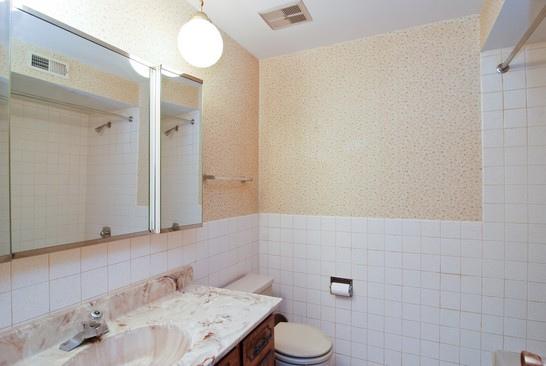Is the light on?
Give a very brief answer. Yes. Is their toilet paper?
Write a very short answer. Yes. Is this a clean room?
Keep it brief. Yes. Do the walls have wallpaper on them?
Concise answer only. Yes. Is there a bottle of liquid soap next to the sink?
Short answer required. No. 